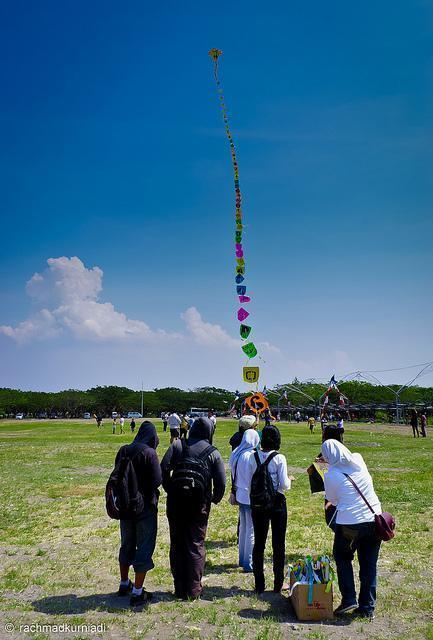How many people are in the picture?
Give a very brief answer. 6. How many polar bears are there?
Give a very brief answer. 0. 